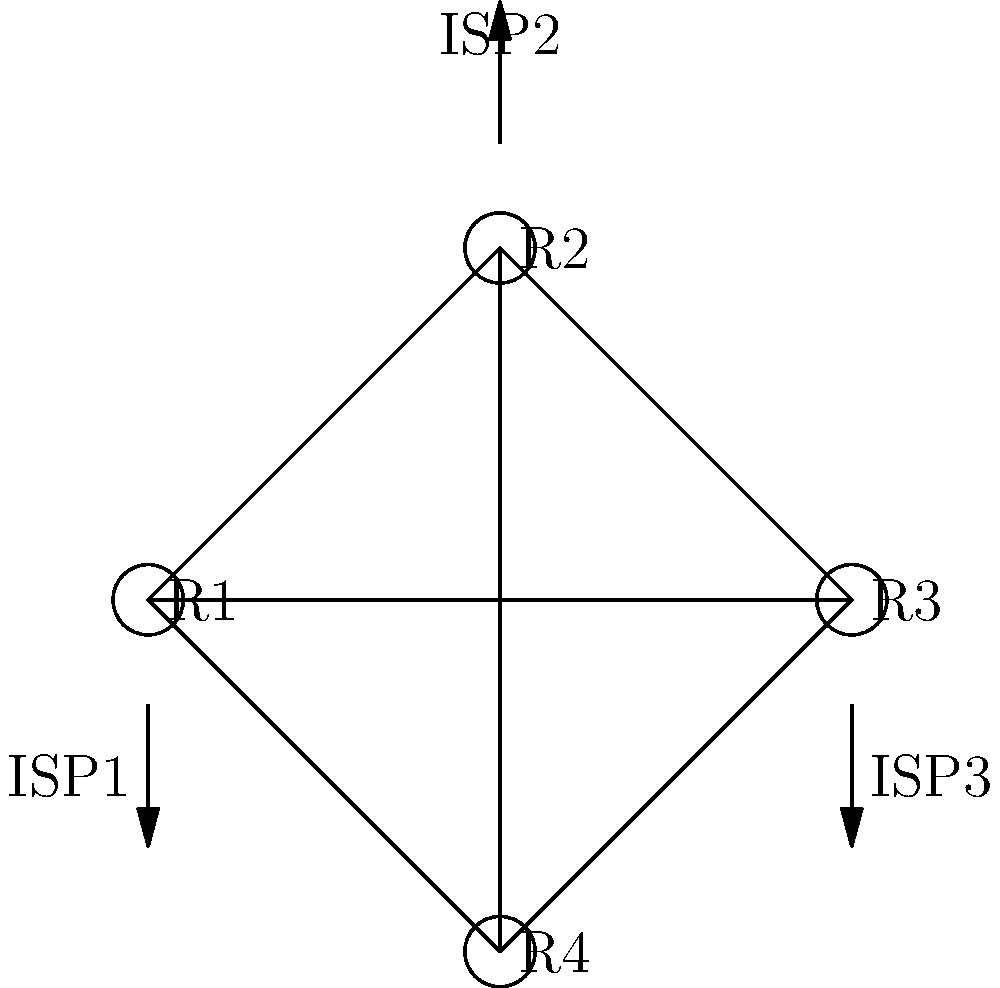In the given network topology for a data center with multiple ISP connections, which routing protocol would be most suitable for achieving fast convergence and load balancing across the available paths? To determine the most suitable routing protocol for this data center network topology with multiple ISP connections, we need to consider several factors:

1. Redundancy: The topology shows a fully meshed network with four routers (R1, R2, R3, R4) and three ISP connections.

2. Fast convergence: In case of link failures, the protocol should quickly adapt to network changes.

3. Load balancing: The protocol should efficiently utilize all available paths.

4. Multiple ISP support: The chosen protocol must handle external routing with multiple ISPs.

5. Scalability: The protocol should be able to handle potential growth in the network.

Considering these factors, the most suitable routing protocol for this scenario would be BGP (Border Gateway Protocol) with ECMP (Equal-Cost Multi-Path) routing. Here's why:

1. BGP is designed for inter-domain routing and can handle multiple ISP connections effectively.

2. BGP with BFD (Bidirectional Forwarding Detection) can achieve fast convergence in case of link failures.

3. ECMP allows for load balancing across multiple equal-cost paths, utilizing all available connections.

4. BGP can be used for both internal (iBGP) and external (eBGP) routing, providing a unified solution for the entire network.

5. BGP is highly scalable and can handle large routing tables, making it suitable for potential network growth.

6. BGP allows for fine-grained traffic engineering through various attributes and policies.

While other protocols like OSPF or IS-IS could be used for internal routing, BGP with ECMP provides the most comprehensive solution for this specific topology with multiple ISP connections and the need for fast convergence and load balancing.
Answer: BGP with ECMP 